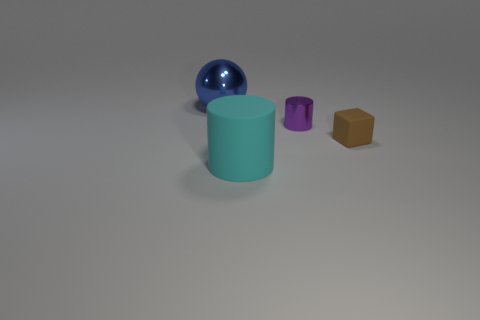Add 1 tiny brown cylinders. How many objects exist? 5 Subtract all spheres. How many objects are left? 3 Add 4 metal objects. How many metal objects exist? 6 Subtract 0 gray spheres. How many objects are left? 4 Subtract all big cyan shiny balls. Subtract all cyan rubber objects. How many objects are left? 3 Add 1 brown matte objects. How many brown matte objects are left? 2 